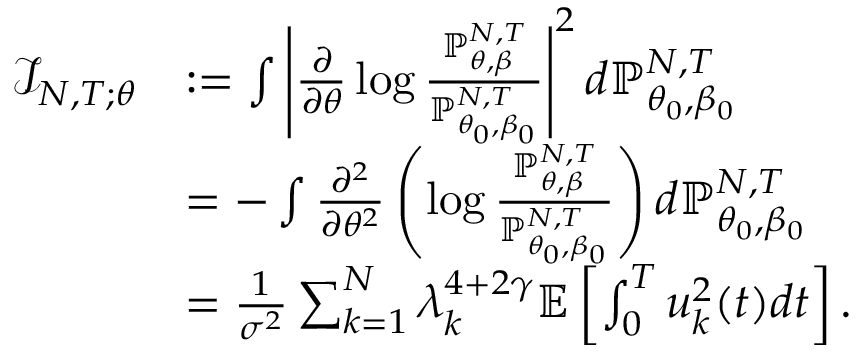Convert formula to latex. <formula><loc_0><loc_0><loc_500><loc_500>\begin{array} { r l } { \mathcal { I } _ { N , T ; \theta } } & { \colon = \int \left | \frac { \partial } { \partial \theta } \log \frac { \mathbb { P } _ { \theta , \beta } ^ { N , T } } { \mathbb { P } _ { \theta _ { 0 } , \beta _ { 0 } } ^ { N , T } } \right | ^ { 2 } d \mathbb { P } _ { \theta _ { 0 } , \beta _ { 0 } } ^ { N , T } } \\ & { = - \int \frac { \partial ^ { 2 } } { \partial \theta ^ { 2 } } \left ( \log \frac { \mathbb { P } _ { \theta , \beta } ^ { N , T } } { \mathbb { P } _ { \theta _ { 0 } , \beta _ { 0 } } ^ { N , T } } \right ) d \mathbb { P } _ { \theta _ { 0 } , \beta _ { 0 } } ^ { N , T } } \\ & { = \frac { 1 } { \sigma ^ { 2 } } \sum _ { k = 1 } ^ { N } \lambda _ { k } ^ { 4 + 2 \gamma } \mathbb { E } \left [ \int _ { 0 } ^ { T } u _ { k } ^ { 2 } ( t ) d t \right ] . } \end{array}</formula> 